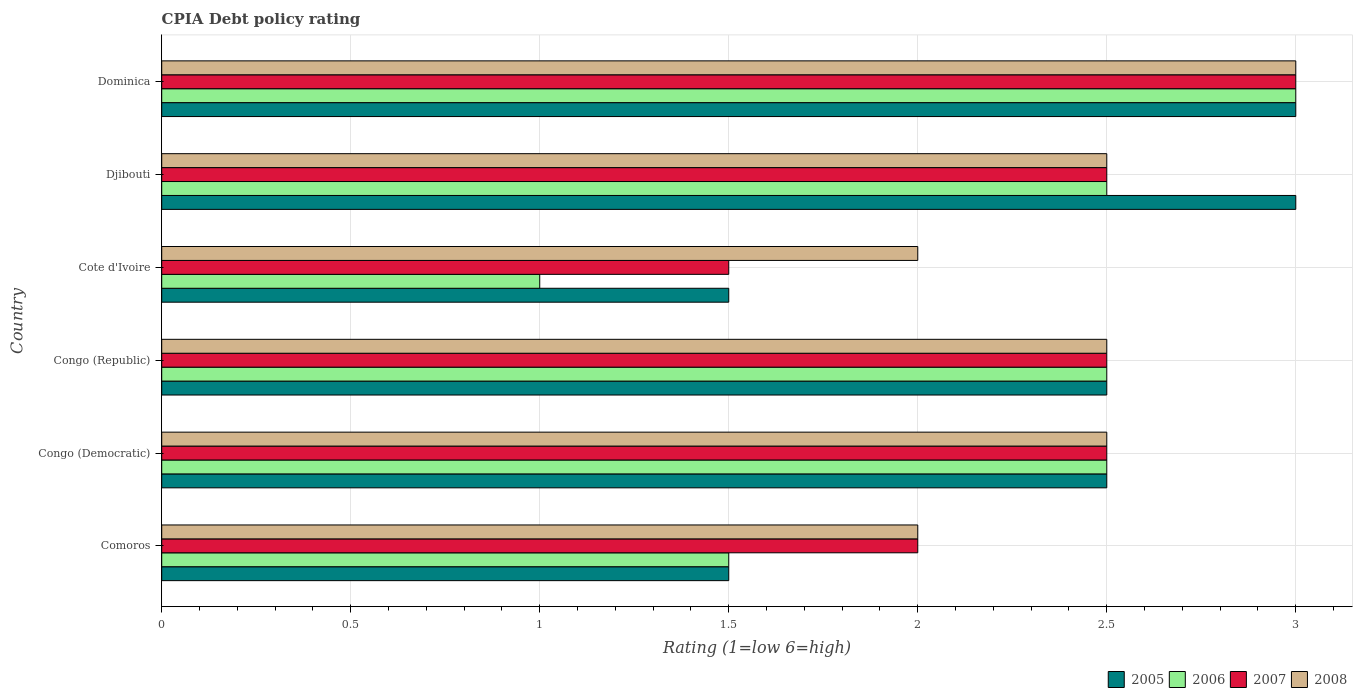Are the number of bars on each tick of the Y-axis equal?
Keep it short and to the point. Yes. How many bars are there on the 2nd tick from the top?
Offer a very short reply. 4. What is the label of the 5th group of bars from the top?
Your answer should be compact. Congo (Democratic). Across all countries, what is the maximum CPIA rating in 2007?
Provide a short and direct response. 3. Across all countries, what is the minimum CPIA rating in 2008?
Make the answer very short. 2. In which country was the CPIA rating in 2008 maximum?
Your answer should be very brief. Dominica. In which country was the CPIA rating in 2008 minimum?
Make the answer very short. Comoros. What is the average CPIA rating in 2006 per country?
Offer a terse response. 2.17. What is the difference between the CPIA rating in 2007 and CPIA rating in 2006 in Dominica?
Ensure brevity in your answer.  0. In how many countries, is the CPIA rating in 2008 greater than 0.30000000000000004 ?
Your answer should be compact. 6. What is the ratio of the CPIA rating in 2007 in Congo (Democratic) to that in Dominica?
Offer a very short reply. 0.83. What is the difference between the highest and the second highest CPIA rating in 2006?
Make the answer very short. 0.5. In how many countries, is the CPIA rating in 2007 greater than the average CPIA rating in 2007 taken over all countries?
Ensure brevity in your answer.  4. Is the sum of the CPIA rating in 2005 in Cote d'Ivoire and Dominica greater than the maximum CPIA rating in 2008 across all countries?
Give a very brief answer. Yes. What does the 1st bar from the top in Cote d'Ivoire represents?
Keep it short and to the point. 2008. How many bars are there?
Offer a very short reply. 24. Are all the bars in the graph horizontal?
Offer a very short reply. Yes. Are the values on the major ticks of X-axis written in scientific E-notation?
Provide a succinct answer. No. Does the graph contain grids?
Provide a short and direct response. Yes. Where does the legend appear in the graph?
Provide a short and direct response. Bottom right. How are the legend labels stacked?
Offer a terse response. Horizontal. What is the title of the graph?
Offer a very short reply. CPIA Debt policy rating. Does "1975" appear as one of the legend labels in the graph?
Ensure brevity in your answer.  No. What is the label or title of the X-axis?
Your answer should be very brief. Rating (1=low 6=high). What is the Rating (1=low 6=high) of 2006 in Comoros?
Ensure brevity in your answer.  1.5. What is the Rating (1=low 6=high) of 2007 in Comoros?
Ensure brevity in your answer.  2. What is the Rating (1=low 6=high) in 2008 in Comoros?
Give a very brief answer. 2. What is the Rating (1=low 6=high) in 2005 in Congo (Democratic)?
Provide a short and direct response. 2.5. What is the Rating (1=low 6=high) of 2007 in Congo (Democratic)?
Your response must be concise. 2.5. What is the Rating (1=low 6=high) in 2008 in Congo (Democratic)?
Your answer should be compact. 2.5. What is the Rating (1=low 6=high) of 2008 in Congo (Republic)?
Provide a succinct answer. 2.5. What is the Rating (1=low 6=high) of 2006 in Cote d'Ivoire?
Your answer should be very brief. 1. What is the Rating (1=low 6=high) of 2008 in Cote d'Ivoire?
Offer a terse response. 2. What is the Rating (1=low 6=high) in 2005 in Djibouti?
Your answer should be very brief. 3. What is the Rating (1=low 6=high) in 2008 in Djibouti?
Provide a short and direct response. 2.5. What is the Rating (1=low 6=high) in 2005 in Dominica?
Offer a very short reply. 3. What is the Rating (1=low 6=high) of 2006 in Dominica?
Ensure brevity in your answer.  3. What is the Rating (1=low 6=high) of 2008 in Dominica?
Provide a short and direct response. 3. Across all countries, what is the maximum Rating (1=low 6=high) in 2007?
Your answer should be compact. 3. Across all countries, what is the maximum Rating (1=low 6=high) in 2008?
Provide a succinct answer. 3. Across all countries, what is the minimum Rating (1=low 6=high) in 2005?
Provide a succinct answer. 1.5. Across all countries, what is the minimum Rating (1=low 6=high) in 2007?
Ensure brevity in your answer.  1.5. What is the total Rating (1=low 6=high) in 2007 in the graph?
Ensure brevity in your answer.  14. What is the difference between the Rating (1=low 6=high) of 2008 in Comoros and that in Congo (Democratic)?
Offer a terse response. -0.5. What is the difference between the Rating (1=low 6=high) in 2005 in Comoros and that in Congo (Republic)?
Offer a very short reply. -1. What is the difference between the Rating (1=low 6=high) of 2008 in Comoros and that in Congo (Republic)?
Your response must be concise. -0.5. What is the difference between the Rating (1=low 6=high) of 2006 in Comoros and that in Cote d'Ivoire?
Your response must be concise. 0.5. What is the difference between the Rating (1=low 6=high) in 2005 in Comoros and that in Djibouti?
Offer a terse response. -1.5. What is the difference between the Rating (1=low 6=high) in 2006 in Comoros and that in Djibouti?
Offer a very short reply. -1. What is the difference between the Rating (1=low 6=high) of 2008 in Comoros and that in Djibouti?
Your answer should be compact. -0.5. What is the difference between the Rating (1=low 6=high) in 2006 in Comoros and that in Dominica?
Your response must be concise. -1.5. What is the difference between the Rating (1=low 6=high) in 2007 in Comoros and that in Dominica?
Give a very brief answer. -1. What is the difference between the Rating (1=low 6=high) of 2006 in Congo (Democratic) and that in Congo (Republic)?
Provide a short and direct response. 0. What is the difference between the Rating (1=low 6=high) of 2007 in Congo (Democratic) and that in Congo (Republic)?
Your answer should be very brief. 0. What is the difference between the Rating (1=low 6=high) in 2008 in Congo (Democratic) and that in Cote d'Ivoire?
Provide a succinct answer. 0.5. What is the difference between the Rating (1=low 6=high) of 2008 in Congo (Democratic) and that in Djibouti?
Make the answer very short. 0. What is the difference between the Rating (1=low 6=high) in 2007 in Congo (Democratic) and that in Dominica?
Make the answer very short. -0.5. What is the difference between the Rating (1=low 6=high) in 2008 in Congo (Democratic) and that in Dominica?
Your response must be concise. -0.5. What is the difference between the Rating (1=low 6=high) of 2006 in Congo (Republic) and that in Cote d'Ivoire?
Your answer should be compact. 1.5. What is the difference between the Rating (1=low 6=high) of 2007 in Congo (Republic) and that in Cote d'Ivoire?
Ensure brevity in your answer.  1. What is the difference between the Rating (1=low 6=high) in 2005 in Congo (Republic) and that in Djibouti?
Your response must be concise. -0.5. What is the difference between the Rating (1=low 6=high) of 2006 in Congo (Republic) and that in Djibouti?
Offer a very short reply. 0. What is the difference between the Rating (1=low 6=high) in 2007 in Congo (Republic) and that in Djibouti?
Your answer should be compact. 0. What is the difference between the Rating (1=low 6=high) of 2005 in Congo (Republic) and that in Dominica?
Your answer should be compact. -0.5. What is the difference between the Rating (1=low 6=high) in 2008 in Congo (Republic) and that in Dominica?
Ensure brevity in your answer.  -0.5. What is the difference between the Rating (1=low 6=high) of 2007 in Cote d'Ivoire and that in Djibouti?
Offer a terse response. -1. What is the difference between the Rating (1=low 6=high) in 2005 in Cote d'Ivoire and that in Dominica?
Offer a terse response. -1.5. What is the difference between the Rating (1=low 6=high) in 2007 in Cote d'Ivoire and that in Dominica?
Keep it short and to the point. -1.5. What is the difference between the Rating (1=low 6=high) of 2008 in Cote d'Ivoire and that in Dominica?
Provide a short and direct response. -1. What is the difference between the Rating (1=low 6=high) in 2005 in Djibouti and that in Dominica?
Keep it short and to the point. 0. What is the difference between the Rating (1=low 6=high) in 2007 in Djibouti and that in Dominica?
Offer a very short reply. -0.5. What is the difference between the Rating (1=low 6=high) of 2005 in Comoros and the Rating (1=low 6=high) of 2006 in Congo (Democratic)?
Offer a terse response. -1. What is the difference between the Rating (1=low 6=high) in 2006 in Comoros and the Rating (1=low 6=high) in 2007 in Congo (Democratic)?
Provide a short and direct response. -1. What is the difference between the Rating (1=low 6=high) in 2006 in Comoros and the Rating (1=low 6=high) in 2008 in Congo (Democratic)?
Your response must be concise. -1. What is the difference between the Rating (1=low 6=high) in 2007 in Comoros and the Rating (1=low 6=high) in 2008 in Congo (Democratic)?
Your answer should be very brief. -0.5. What is the difference between the Rating (1=low 6=high) in 2005 in Comoros and the Rating (1=low 6=high) in 2006 in Congo (Republic)?
Give a very brief answer. -1. What is the difference between the Rating (1=low 6=high) in 2005 in Comoros and the Rating (1=low 6=high) in 2008 in Congo (Republic)?
Your response must be concise. -1. What is the difference between the Rating (1=low 6=high) in 2006 in Comoros and the Rating (1=low 6=high) in 2007 in Congo (Republic)?
Offer a terse response. -1. What is the difference between the Rating (1=low 6=high) of 2005 in Comoros and the Rating (1=low 6=high) of 2006 in Cote d'Ivoire?
Make the answer very short. 0.5. What is the difference between the Rating (1=low 6=high) of 2005 in Comoros and the Rating (1=low 6=high) of 2007 in Cote d'Ivoire?
Offer a terse response. 0. What is the difference between the Rating (1=low 6=high) of 2006 in Comoros and the Rating (1=low 6=high) of 2008 in Cote d'Ivoire?
Provide a succinct answer. -0.5. What is the difference between the Rating (1=low 6=high) in 2007 in Comoros and the Rating (1=low 6=high) in 2008 in Cote d'Ivoire?
Make the answer very short. 0. What is the difference between the Rating (1=low 6=high) of 2005 in Comoros and the Rating (1=low 6=high) of 2006 in Djibouti?
Ensure brevity in your answer.  -1. What is the difference between the Rating (1=low 6=high) in 2006 in Comoros and the Rating (1=low 6=high) in 2008 in Djibouti?
Ensure brevity in your answer.  -1. What is the difference between the Rating (1=low 6=high) in 2007 in Comoros and the Rating (1=low 6=high) in 2008 in Djibouti?
Provide a short and direct response. -0.5. What is the difference between the Rating (1=low 6=high) in 2005 in Comoros and the Rating (1=low 6=high) in 2006 in Dominica?
Ensure brevity in your answer.  -1.5. What is the difference between the Rating (1=low 6=high) in 2005 in Comoros and the Rating (1=low 6=high) in 2007 in Dominica?
Your answer should be very brief. -1.5. What is the difference between the Rating (1=low 6=high) of 2006 in Comoros and the Rating (1=low 6=high) of 2007 in Dominica?
Make the answer very short. -1.5. What is the difference between the Rating (1=low 6=high) of 2006 in Comoros and the Rating (1=low 6=high) of 2008 in Dominica?
Make the answer very short. -1.5. What is the difference between the Rating (1=low 6=high) of 2005 in Congo (Democratic) and the Rating (1=low 6=high) of 2006 in Congo (Republic)?
Your answer should be very brief. 0. What is the difference between the Rating (1=low 6=high) in 2005 in Congo (Democratic) and the Rating (1=low 6=high) in 2007 in Congo (Republic)?
Provide a short and direct response. 0. What is the difference between the Rating (1=low 6=high) of 2006 in Congo (Democratic) and the Rating (1=low 6=high) of 2007 in Congo (Republic)?
Keep it short and to the point. 0. What is the difference between the Rating (1=low 6=high) in 2007 in Congo (Democratic) and the Rating (1=low 6=high) in 2008 in Congo (Republic)?
Your response must be concise. 0. What is the difference between the Rating (1=low 6=high) in 2005 in Congo (Democratic) and the Rating (1=low 6=high) in 2006 in Cote d'Ivoire?
Offer a terse response. 1.5. What is the difference between the Rating (1=low 6=high) in 2007 in Congo (Democratic) and the Rating (1=low 6=high) in 2008 in Cote d'Ivoire?
Keep it short and to the point. 0.5. What is the difference between the Rating (1=low 6=high) of 2005 in Congo (Democratic) and the Rating (1=low 6=high) of 2006 in Djibouti?
Keep it short and to the point. 0. What is the difference between the Rating (1=low 6=high) in 2005 in Congo (Democratic) and the Rating (1=low 6=high) in 2007 in Djibouti?
Provide a succinct answer. 0. What is the difference between the Rating (1=low 6=high) of 2005 in Congo (Democratic) and the Rating (1=low 6=high) of 2007 in Dominica?
Your answer should be very brief. -0.5. What is the difference between the Rating (1=low 6=high) in 2006 in Congo (Democratic) and the Rating (1=low 6=high) in 2008 in Dominica?
Ensure brevity in your answer.  -0.5. What is the difference between the Rating (1=low 6=high) of 2007 in Congo (Democratic) and the Rating (1=low 6=high) of 2008 in Dominica?
Your answer should be very brief. -0.5. What is the difference between the Rating (1=low 6=high) in 2005 in Congo (Republic) and the Rating (1=low 6=high) in 2008 in Cote d'Ivoire?
Make the answer very short. 0.5. What is the difference between the Rating (1=low 6=high) of 2006 in Congo (Republic) and the Rating (1=low 6=high) of 2008 in Cote d'Ivoire?
Your answer should be compact. 0.5. What is the difference between the Rating (1=low 6=high) in 2007 in Congo (Republic) and the Rating (1=low 6=high) in 2008 in Cote d'Ivoire?
Offer a terse response. 0.5. What is the difference between the Rating (1=low 6=high) of 2005 in Congo (Republic) and the Rating (1=low 6=high) of 2006 in Djibouti?
Provide a short and direct response. 0. What is the difference between the Rating (1=low 6=high) of 2005 in Congo (Republic) and the Rating (1=low 6=high) of 2007 in Djibouti?
Your response must be concise. 0. What is the difference between the Rating (1=low 6=high) in 2005 in Congo (Republic) and the Rating (1=low 6=high) in 2008 in Djibouti?
Your answer should be very brief. 0. What is the difference between the Rating (1=low 6=high) in 2006 in Congo (Republic) and the Rating (1=low 6=high) in 2007 in Djibouti?
Your answer should be compact. 0. What is the difference between the Rating (1=low 6=high) in 2006 in Congo (Republic) and the Rating (1=low 6=high) in 2008 in Djibouti?
Make the answer very short. 0. What is the difference between the Rating (1=low 6=high) in 2007 in Congo (Republic) and the Rating (1=low 6=high) in 2008 in Djibouti?
Provide a succinct answer. 0. What is the difference between the Rating (1=low 6=high) of 2005 in Congo (Republic) and the Rating (1=low 6=high) of 2008 in Dominica?
Keep it short and to the point. -0.5. What is the difference between the Rating (1=low 6=high) in 2006 in Congo (Republic) and the Rating (1=low 6=high) in 2008 in Dominica?
Provide a short and direct response. -0.5. What is the difference between the Rating (1=low 6=high) of 2005 in Cote d'Ivoire and the Rating (1=low 6=high) of 2007 in Djibouti?
Ensure brevity in your answer.  -1. What is the difference between the Rating (1=low 6=high) of 2005 in Cote d'Ivoire and the Rating (1=low 6=high) of 2008 in Djibouti?
Make the answer very short. -1. What is the difference between the Rating (1=low 6=high) in 2006 in Cote d'Ivoire and the Rating (1=low 6=high) in 2008 in Djibouti?
Ensure brevity in your answer.  -1.5. What is the difference between the Rating (1=low 6=high) in 2007 in Cote d'Ivoire and the Rating (1=low 6=high) in 2008 in Djibouti?
Give a very brief answer. -1. What is the difference between the Rating (1=low 6=high) of 2006 in Cote d'Ivoire and the Rating (1=low 6=high) of 2008 in Dominica?
Keep it short and to the point. -2. What is the difference between the Rating (1=low 6=high) of 2007 in Cote d'Ivoire and the Rating (1=low 6=high) of 2008 in Dominica?
Make the answer very short. -1.5. What is the difference between the Rating (1=low 6=high) of 2005 in Djibouti and the Rating (1=low 6=high) of 2007 in Dominica?
Your answer should be compact. 0. What is the difference between the Rating (1=low 6=high) of 2005 in Djibouti and the Rating (1=low 6=high) of 2008 in Dominica?
Give a very brief answer. 0. What is the difference between the Rating (1=low 6=high) of 2006 in Djibouti and the Rating (1=low 6=high) of 2007 in Dominica?
Ensure brevity in your answer.  -0.5. What is the difference between the Rating (1=low 6=high) in 2006 in Djibouti and the Rating (1=low 6=high) in 2008 in Dominica?
Provide a short and direct response. -0.5. What is the average Rating (1=low 6=high) of 2005 per country?
Offer a very short reply. 2.33. What is the average Rating (1=low 6=high) of 2006 per country?
Your answer should be compact. 2.17. What is the average Rating (1=low 6=high) in 2007 per country?
Give a very brief answer. 2.33. What is the average Rating (1=low 6=high) in 2008 per country?
Offer a very short reply. 2.42. What is the difference between the Rating (1=low 6=high) of 2005 and Rating (1=low 6=high) of 2008 in Comoros?
Make the answer very short. -0.5. What is the difference between the Rating (1=low 6=high) in 2005 and Rating (1=low 6=high) in 2006 in Congo (Democratic)?
Ensure brevity in your answer.  0. What is the difference between the Rating (1=low 6=high) of 2006 and Rating (1=low 6=high) of 2008 in Congo (Democratic)?
Offer a very short reply. 0. What is the difference between the Rating (1=low 6=high) in 2007 and Rating (1=low 6=high) in 2008 in Congo (Democratic)?
Your answer should be very brief. 0. What is the difference between the Rating (1=low 6=high) in 2005 and Rating (1=low 6=high) in 2008 in Congo (Republic)?
Keep it short and to the point. 0. What is the difference between the Rating (1=low 6=high) in 2005 and Rating (1=low 6=high) in 2006 in Cote d'Ivoire?
Ensure brevity in your answer.  0.5. What is the difference between the Rating (1=low 6=high) in 2005 and Rating (1=low 6=high) in 2008 in Cote d'Ivoire?
Your answer should be very brief. -0.5. What is the difference between the Rating (1=low 6=high) in 2007 and Rating (1=low 6=high) in 2008 in Cote d'Ivoire?
Offer a very short reply. -0.5. What is the difference between the Rating (1=low 6=high) of 2005 and Rating (1=low 6=high) of 2008 in Djibouti?
Provide a succinct answer. 0.5. What is the difference between the Rating (1=low 6=high) of 2006 and Rating (1=low 6=high) of 2007 in Djibouti?
Make the answer very short. 0. What is the difference between the Rating (1=low 6=high) of 2006 and Rating (1=low 6=high) of 2008 in Djibouti?
Ensure brevity in your answer.  0. What is the difference between the Rating (1=low 6=high) in 2007 and Rating (1=low 6=high) in 2008 in Djibouti?
Provide a succinct answer. 0. What is the difference between the Rating (1=low 6=high) of 2005 and Rating (1=low 6=high) of 2007 in Dominica?
Keep it short and to the point. 0. What is the difference between the Rating (1=low 6=high) in 2005 and Rating (1=low 6=high) in 2008 in Dominica?
Your answer should be very brief. 0. What is the difference between the Rating (1=low 6=high) in 2006 and Rating (1=low 6=high) in 2007 in Dominica?
Your response must be concise. 0. What is the ratio of the Rating (1=low 6=high) in 2005 in Comoros to that in Congo (Democratic)?
Offer a terse response. 0.6. What is the ratio of the Rating (1=low 6=high) of 2006 in Comoros to that in Congo (Democratic)?
Make the answer very short. 0.6. What is the ratio of the Rating (1=low 6=high) of 2007 in Comoros to that in Congo (Democratic)?
Ensure brevity in your answer.  0.8. What is the ratio of the Rating (1=low 6=high) of 2006 in Comoros to that in Congo (Republic)?
Your response must be concise. 0.6. What is the ratio of the Rating (1=low 6=high) in 2008 in Comoros to that in Congo (Republic)?
Provide a succinct answer. 0.8. What is the ratio of the Rating (1=low 6=high) of 2007 in Comoros to that in Cote d'Ivoire?
Ensure brevity in your answer.  1.33. What is the ratio of the Rating (1=low 6=high) in 2005 in Comoros to that in Djibouti?
Offer a terse response. 0.5. What is the ratio of the Rating (1=low 6=high) in 2007 in Comoros to that in Djibouti?
Ensure brevity in your answer.  0.8. What is the ratio of the Rating (1=low 6=high) in 2006 in Comoros to that in Dominica?
Your answer should be compact. 0.5. What is the ratio of the Rating (1=low 6=high) of 2007 in Comoros to that in Dominica?
Offer a terse response. 0.67. What is the ratio of the Rating (1=low 6=high) in 2005 in Congo (Democratic) to that in Congo (Republic)?
Provide a short and direct response. 1. What is the ratio of the Rating (1=low 6=high) of 2007 in Congo (Democratic) to that in Congo (Republic)?
Your answer should be compact. 1. What is the ratio of the Rating (1=low 6=high) of 2008 in Congo (Democratic) to that in Congo (Republic)?
Offer a very short reply. 1. What is the ratio of the Rating (1=low 6=high) of 2005 in Congo (Democratic) to that in Cote d'Ivoire?
Your answer should be compact. 1.67. What is the ratio of the Rating (1=low 6=high) of 2006 in Congo (Democratic) to that in Cote d'Ivoire?
Ensure brevity in your answer.  2.5. What is the ratio of the Rating (1=low 6=high) of 2008 in Congo (Democratic) to that in Cote d'Ivoire?
Make the answer very short. 1.25. What is the ratio of the Rating (1=low 6=high) in 2005 in Congo (Democratic) to that in Djibouti?
Your response must be concise. 0.83. What is the ratio of the Rating (1=low 6=high) of 2006 in Congo (Democratic) to that in Djibouti?
Keep it short and to the point. 1. What is the ratio of the Rating (1=low 6=high) in 2007 in Congo (Democratic) to that in Djibouti?
Offer a very short reply. 1. What is the ratio of the Rating (1=low 6=high) in 2005 in Congo (Democratic) to that in Dominica?
Your answer should be compact. 0.83. What is the ratio of the Rating (1=low 6=high) in 2007 in Congo (Democratic) to that in Dominica?
Make the answer very short. 0.83. What is the ratio of the Rating (1=low 6=high) in 2005 in Congo (Republic) to that in Cote d'Ivoire?
Your answer should be compact. 1.67. What is the ratio of the Rating (1=low 6=high) of 2006 in Congo (Republic) to that in Cote d'Ivoire?
Provide a succinct answer. 2.5. What is the ratio of the Rating (1=low 6=high) of 2007 in Congo (Republic) to that in Cote d'Ivoire?
Ensure brevity in your answer.  1.67. What is the ratio of the Rating (1=low 6=high) in 2008 in Congo (Republic) to that in Djibouti?
Make the answer very short. 1. What is the ratio of the Rating (1=low 6=high) in 2005 in Congo (Republic) to that in Dominica?
Your answer should be very brief. 0.83. What is the ratio of the Rating (1=low 6=high) in 2006 in Congo (Republic) to that in Dominica?
Offer a terse response. 0.83. What is the ratio of the Rating (1=low 6=high) in 2007 in Congo (Republic) to that in Dominica?
Your response must be concise. 0.83. What is the ratio of the Rating (1=low 6=high) of 2008 in Congo (Republic) to that in Dominica?
Ensure brevity in your answer.  0.83. What is the ratio of the Rating (1=low 6=high) of 2007 in Cote d'Ivoire to that in Djibouti?
Ensure brevity in your answer.  0.6. What is the ratio of the Rating (1=low 6=high) of 2008 in Cote d'Ivoire to that in Djibouti?
Provide a succinct answer. 0.8. What is the ratio of the Rating (1=low 6=high) in 2005 in Cote d'Ivoire to that in Dominica?
Make the answer very short. 0.5. What is the ratio of the Rating (1=low 6=high) of 2007 in Cote d'Ivoire to that in Dominica?
Your response must be concise. 0.5. What is the ratio of the Rating (1=low 6=high) of 2008 in Cote d'Ivoire to that in Dominica?
Your response must be concise. 0.67. What is the ratio of the Rating (1=low 6=high) in 2006 in Djibouti to that in Dominica?
Keep it short and to the point. 0.83. What is the ratio of the Rating (1=low 6=high) of 2007 in Djibouti to that in Dominica?
Your answer should be very brief. 0.83. What is the difference between the highest and the lowest Rating (1=low 6=high) in 2006?
Keep it short and to the point. 2. What is the difference between the highest and the lowest Rating (1=low 6=high) in 2008?
Make the answer very short. 1. 